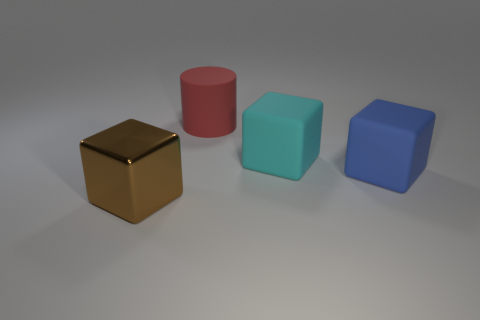Subtract all large cyan matte blocks. How many blocks are left? 2 Add 3 cyan cubes. How many cyan cubes exist? 4 Add 2 big blue matte things. How many objects exist? 6 Subtract all blue blocks. How many blocks are left? 2 Subtract 0 brown cylinders. How many objects are left? 4 Subtract all cylinders. How many objects are left? 3 Subtract all gray blocks. Subtract all purple balls. How many blocks are left? 3 Subtract all yellow cylinders. How many gray cubes are left? 0 Subtract all small gray things. Subtract all matte objects. How many objects are left? 1 Add 4 large cyan objects. How many large cyan objects are left? 5 